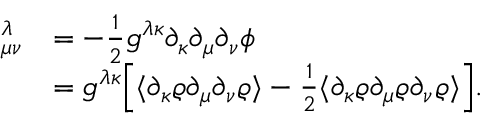<formula> <loc_0><loc_0><loc_500><loc_500>\begin{array} { r l } { \mathbb { \Gamma } _ { \mu \nu } ^ { \lambda } } & { = - \frac { 1 } { 2 } \mathbb { g } ^ { \lambda \kappa } \partial _ { \kappa } \partial _ { \mu } \partial _ { \nu } \phi } \\ & { = \mathbb { g } ^ { \lambda \kappa } \left [ \langle \partial _ { \kappa } \varrho \partial _ { \mu } \partial _ { \nu } \varrho \rangle - \frac { 1 } { 2 } \langle \partial _ { \kappa } \varrho \partial _ { \mu } \varrho \partial _ { \nu } \varrho \rangle \right ] . } \end{array}</formula> 